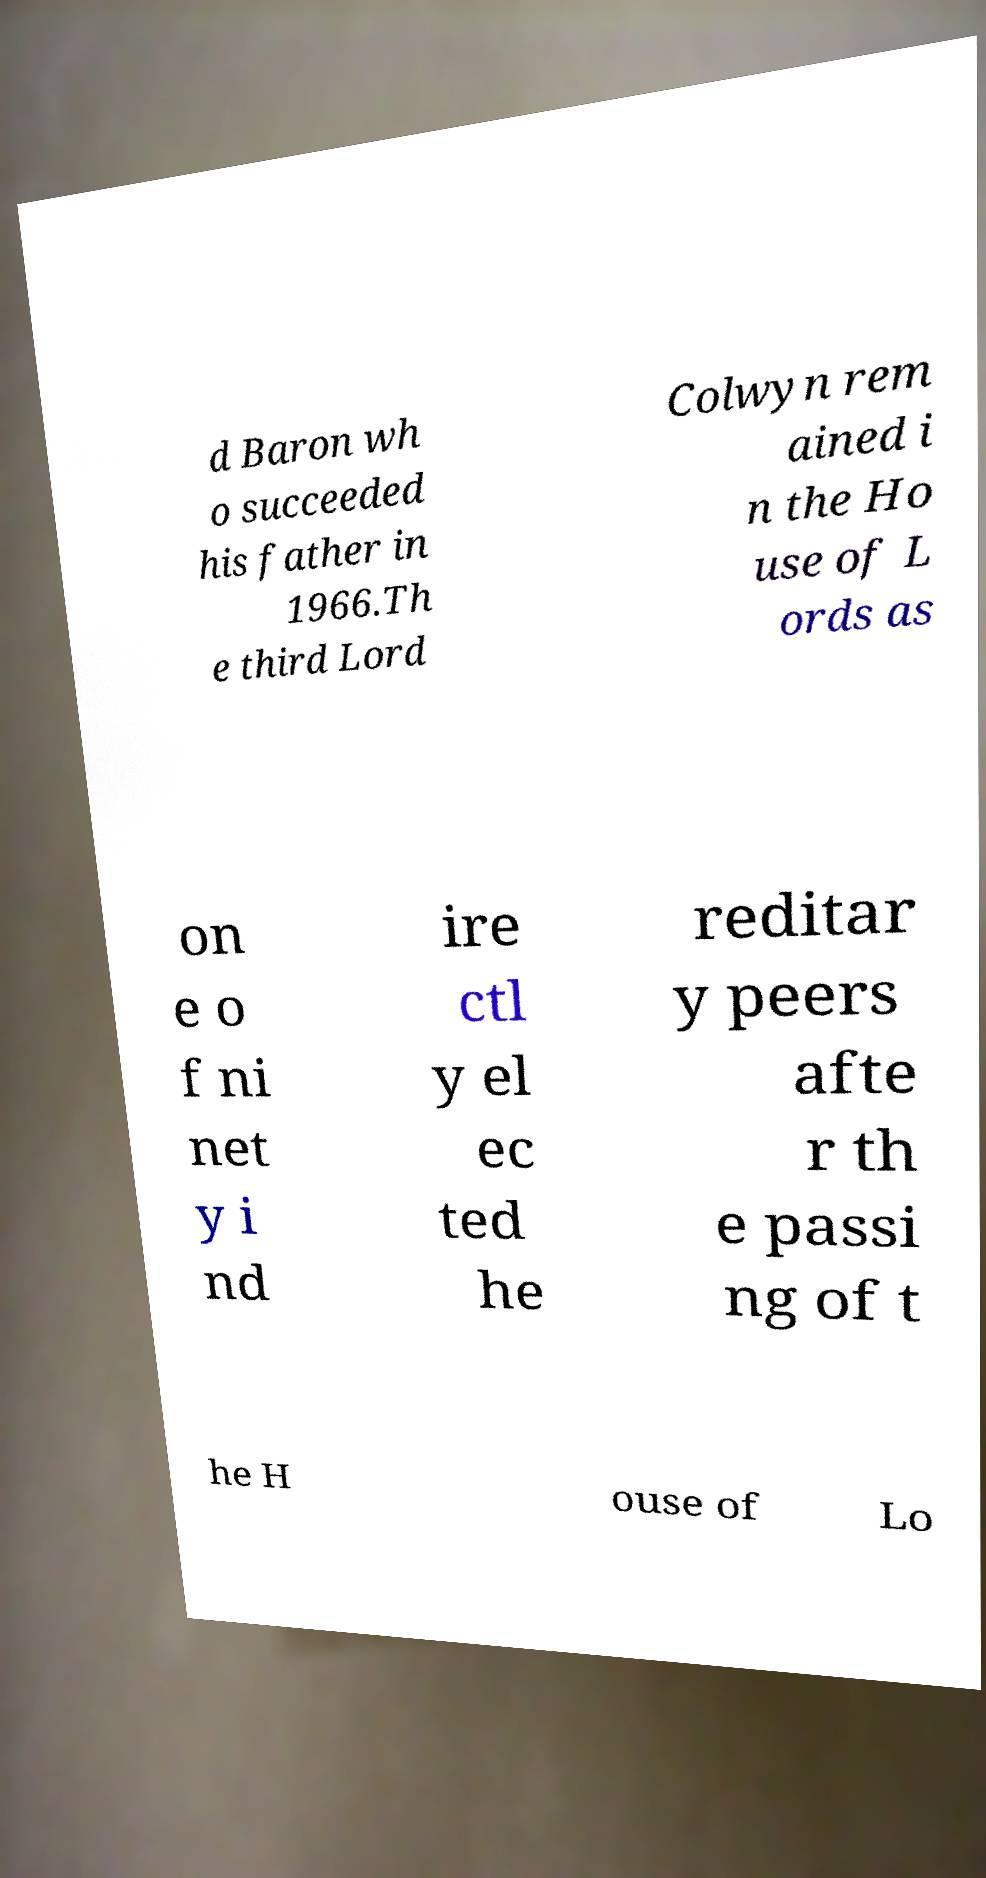Please identify and transcribe the text found in this image. d Baron wh o succeeded his father in 1966.Th e third Lord Colwyn rem ained i n the Ho use of L ords as on e o f ni net y i nd ire ctl y el ec ted he reditar y peers afte r th e passi ng of t he H ouse of Lo 